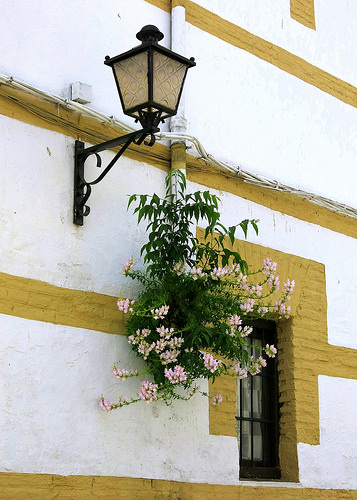<image>
Is there a plant to the left of the fancy lights? No. The plant is not to the left of the fancy lights. From this viewpoint, they have a different horizontal relationship. 